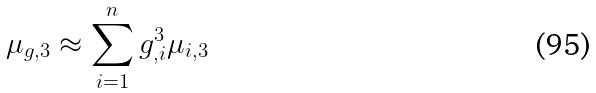Convert formula to latex. <formula><loc_0><loc_0><loc_500><loc_500>\mu _ { g , 3 } \approx \sum _ { i = 1 } ^ { n } g _ { , i } ^ { 3 } \mu _ { i , 3 }</formula> 